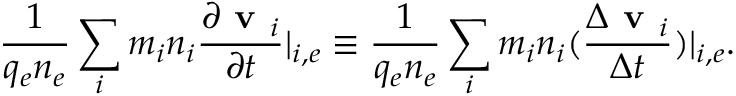<formula> <loc_0><loc_0><loc_500><loc_500>\frac { 1 } { q _ { e } n _ { e } } \sum _ { i } m _ { i } n _ { i } \frac { \partial v _ { i } } { \partial t } | _ { i , e } \equiv \frac { 1 } { q _ { e } n _ { e } } \sum _ { i } m _ { i } n _ { i } ( \frac { \Delta v _ { i } } { \Delta t } ) | _ { i , e } .</formula> 